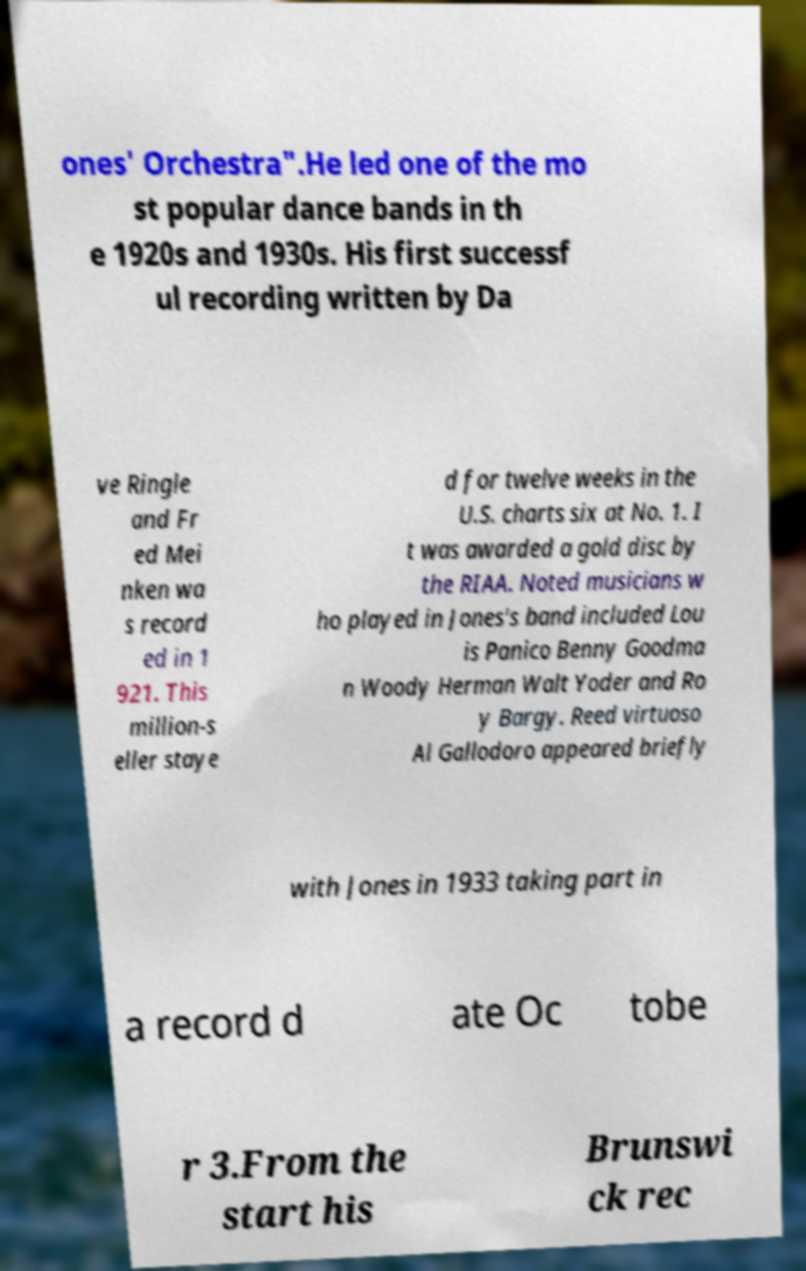Can you read and provide the text displayed in the image?This photo seems to have some interesting text. Can you extract and type it out for me? ones' Orchestra".He led one of the mo st popular dance bands in th e 1920s and 1930s. His first successf ul recording written by Da ve Ringle and Fr ed Mei nken wa s record ed in 1 921. This million-s eller staye d for twelve weeks in the U.S. charts six at No. 1. I t was awarded a gold disc by the RIAA. Noted musicians w ho played in Jones's band included Lou is Panico Benny Goodma n Woody Herman Walt Yoder and Ro y Bargy. Reed virtuoso Al Gallodoro appeared briefly with Jones in 1933 taking part in a record d ate Oc tobe r 3.From the start his Brunswi ck rec 